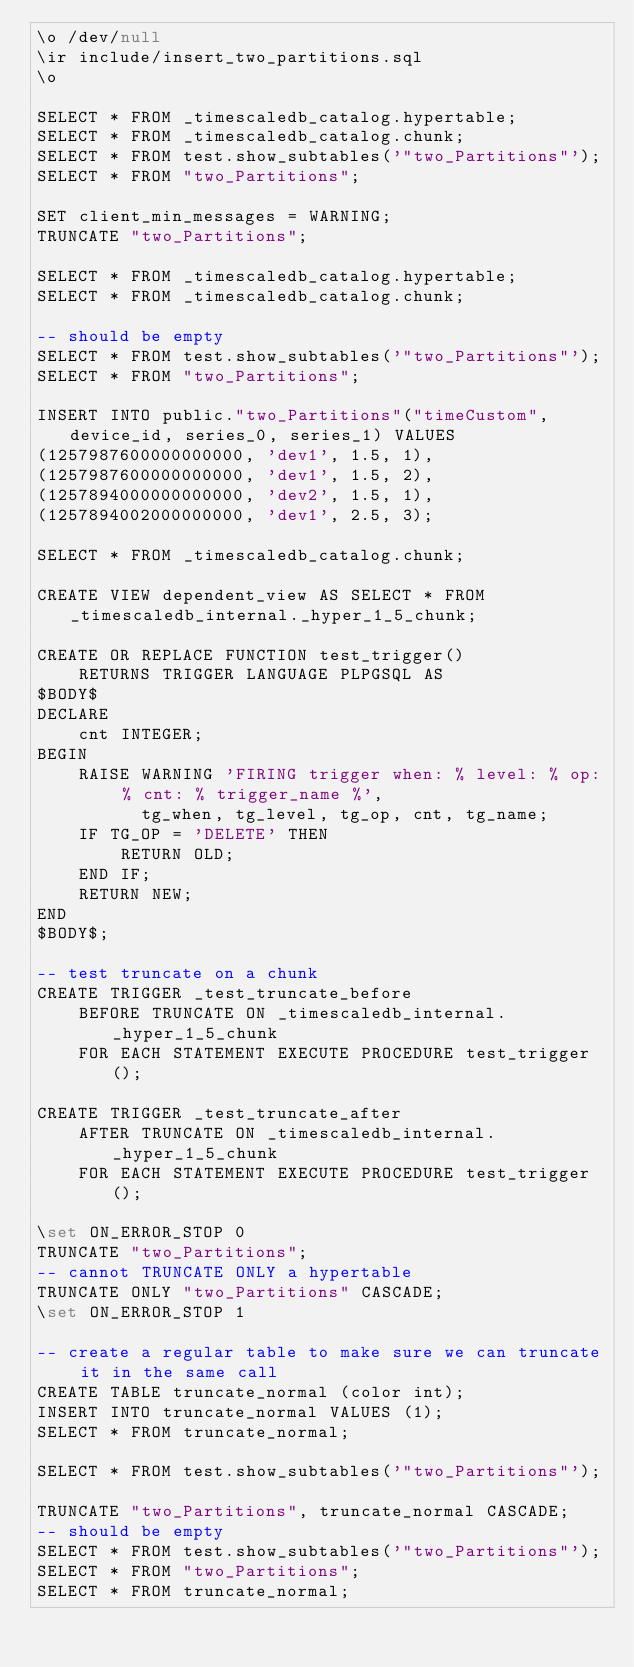<code> <loc_0><loc_0><loc_500><loc_500><_SQL_>\o /dev/null
\ir include/insert_two_partitions.sql
\o

SELECT * FROM _timescaledb_catalog.hypertable;
SELECT * FROM _timescaledb_catalog.chunk;
SELECT * FROM test.show_subtables('"two_Partitions"');
SELECT * FROM "two_Partitions";

SET client_min_messages = WARNING;
TRUNCATE "two_Partitions";

SELECT * FROM _timescaledb_catalog.hypertable;
SELECT * FROM _timescaledb_catalog.chunk;

-- should be empty
SELECT * FROM test.show_subtables('"two_Partitions"');
SELECT * FROM "two_Partitions";

INSERT INTO public."two_Partitions"("timeCustom", device_id, series_0, series_1) VALUES
(1257987600000000000, 'dev1', 1.5, 1),
(1257987600000000000, 'dev1', 1.5, 2),
(1257894000000000000, 'dev2', 1.5, 1),
(1257894002000000000, 'dev1', 2.5, 3);

SELECT * FROM _timescaledb_catalog.chunk;

CREATE VIEW dependent_view AS SELECT * FROM _timescaledb_internal._hyper_1_5_chunk;

CREATE OR REPLACE FUNCTION test_trigger()
    RETURNS TRIGGER LANGUAGE PLPGSQL AS
$BODY$
DECLARE
    cnt INTEGER;
BEGIN
    RAISE WARNING 'FIRING trigger when: % level: % op: % cnt: % trigger_name %',
          tg_when, tg_level, tg_op, cnt, tg_name;
    IF TG_OP = 'DELETE' THEN
        RETURN OLD;
    END IF;
    RETURN NEW;
END
$BODY$;

-- test truncate on a chunk
CREATE TRIGGER _test_truncate_before
    BEFORE TRUNCATE ON _timescaledb_internal._hyper_1_5_chunk
    FOR EACH STATEMENT EXECUTE PROCEDURE test_trigger();

CREATE TRIGGER _test_truncate_after
    AFTER TRUNCATE ON _timescaledb_internal._hyper_1_5_chunk
    FOR EACH STATEMENT EXECUTE PROCEDURE test_trigger();

\set ON_ERROR_STOP 0
TRUNCATE "two_Partitions";
-- cannot TRUNCATE ONLY a hypertable
TRUNCATE ONLY "two_Partitions" CASCADE;
\set ON_ERROR_STOP 1

-- create a regular table to make sure we can truncate it in the same call
CREATE TABLE truncate_normal (color int);
INSERT INTO truncate_normal VALUES (1);
SELECT * FROM truncate_normal;

SELECT * FROM test.show_subtables('"two_Partitions"');

TRUNCATE "two_Partitions", truncate_normal CASCADE;
-- should be empty
SELECT * FROM test.show_subtables('"two_Partitions"');
SELECT * FROM "two_Partitions";
SELECT * FROM truncate_normal;
</code> 